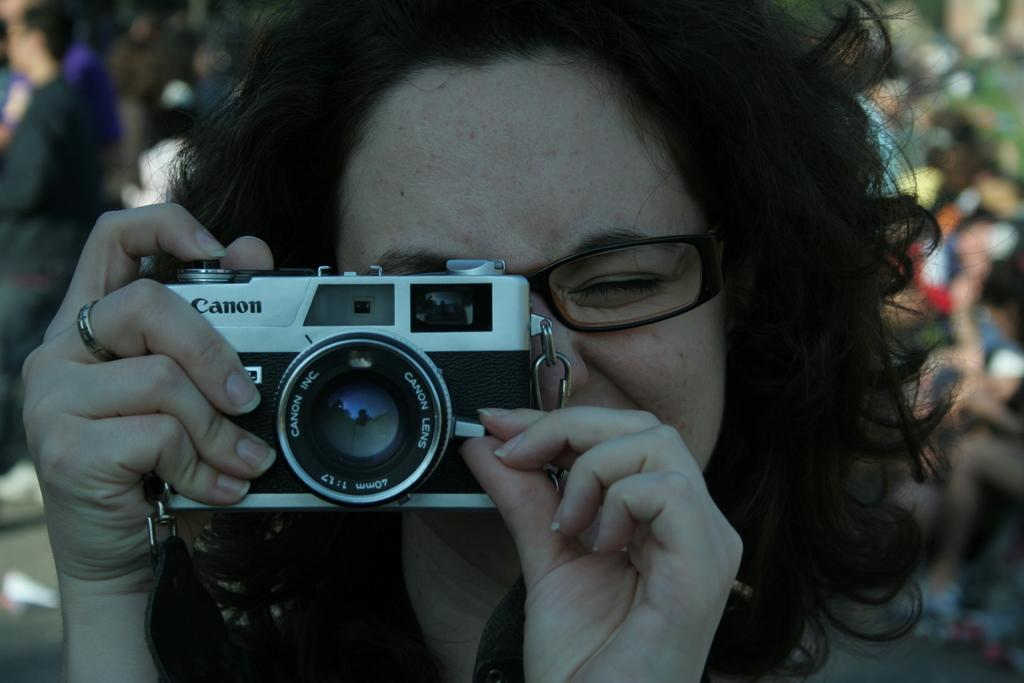Who is the main subject in the image? There is a woman in the image. What is the woman holding in the image? The woman is holding a camera. What accessory is the woman wearing in the image? The woman is wearing spectacles. Can you describe the background of the image? There are people visible in the background of the image. Is the woman in the image wearing a mask? No, the woman is not wearing a mask in the image; she is wearing spectacles. 